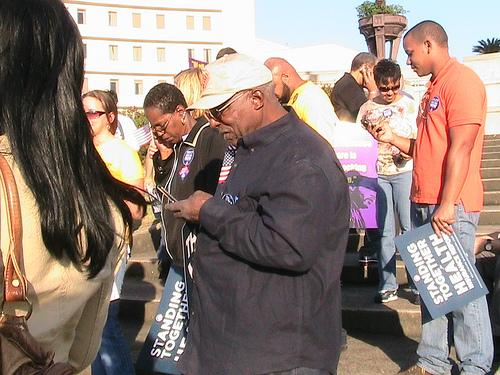What are the main elements of the image? Name at least three. Main elements in the image are an old man, a woman with black hair, and a man in a white hat. Define the scenario depicted in the image: who, what, and where. Several people are present in the image, with a man playing with his phone and a woman wearing black hair and sunglasses, possibly at a gathering or public event. Can you name the primary object this image is focused on and their current activity? The primary object in the image is a man playing with his phone. In the context of visual entailment, what conclusions can you draw from the image? The image entails that the scene takes place during a public event, where people are engaged in various activities such as holding signs, using phones, and wearing different outfits. Explain the scene by mentioning the objects and people present in the background of the image. In the background of the image, there's a tall white building, a statue, a small American flag, and people holding various signs. Choose an action being performed in the image and describe it in detail. A man is using a cell phone, likely browsing or texting, with one hand while standing in a crowd. 